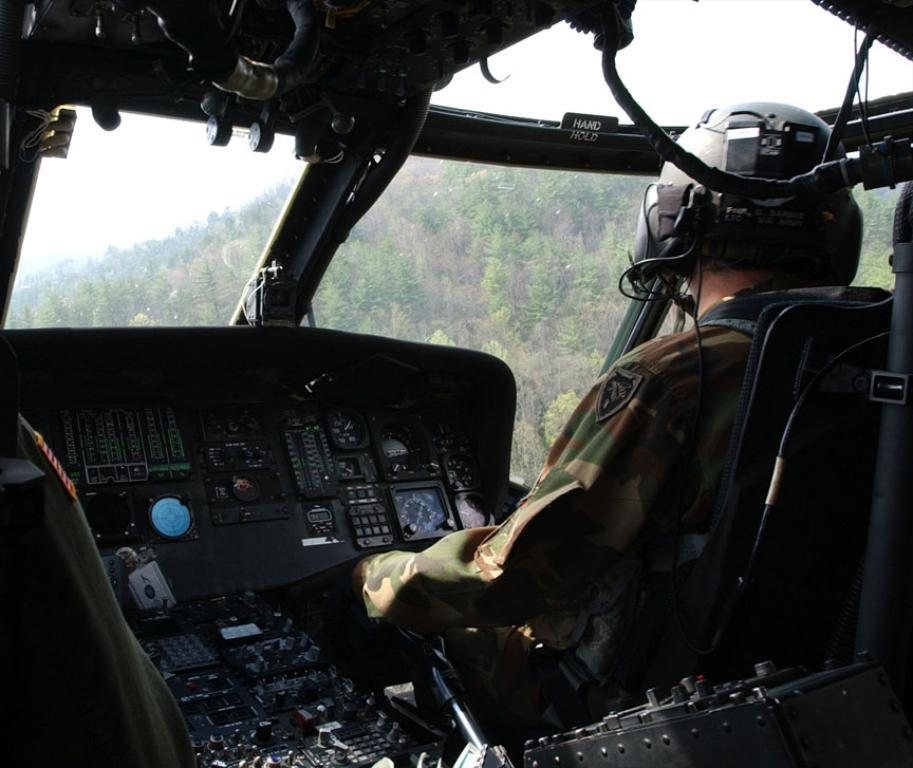What is the main subject in the foreground of the image? There is a person in a helicopter in the foreground of the image. What can be seen in the background of the image? There are trees and the sky visible in the background of the image. Can you describe the time of day when the image was taken? The image was taken during the day. What type of pets can be seen playing with magic in the image? There are no pets or magic present in the image; it features a person in a helicopter with a background of trees and sky. 